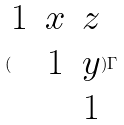<formula> <loc_0><loc_0><loc_500><loc_500>( \begin{matrix} 1 & x & z \\ & 1 & y \\ & & 1 \end{matrix} ) \Gamma</formula> 